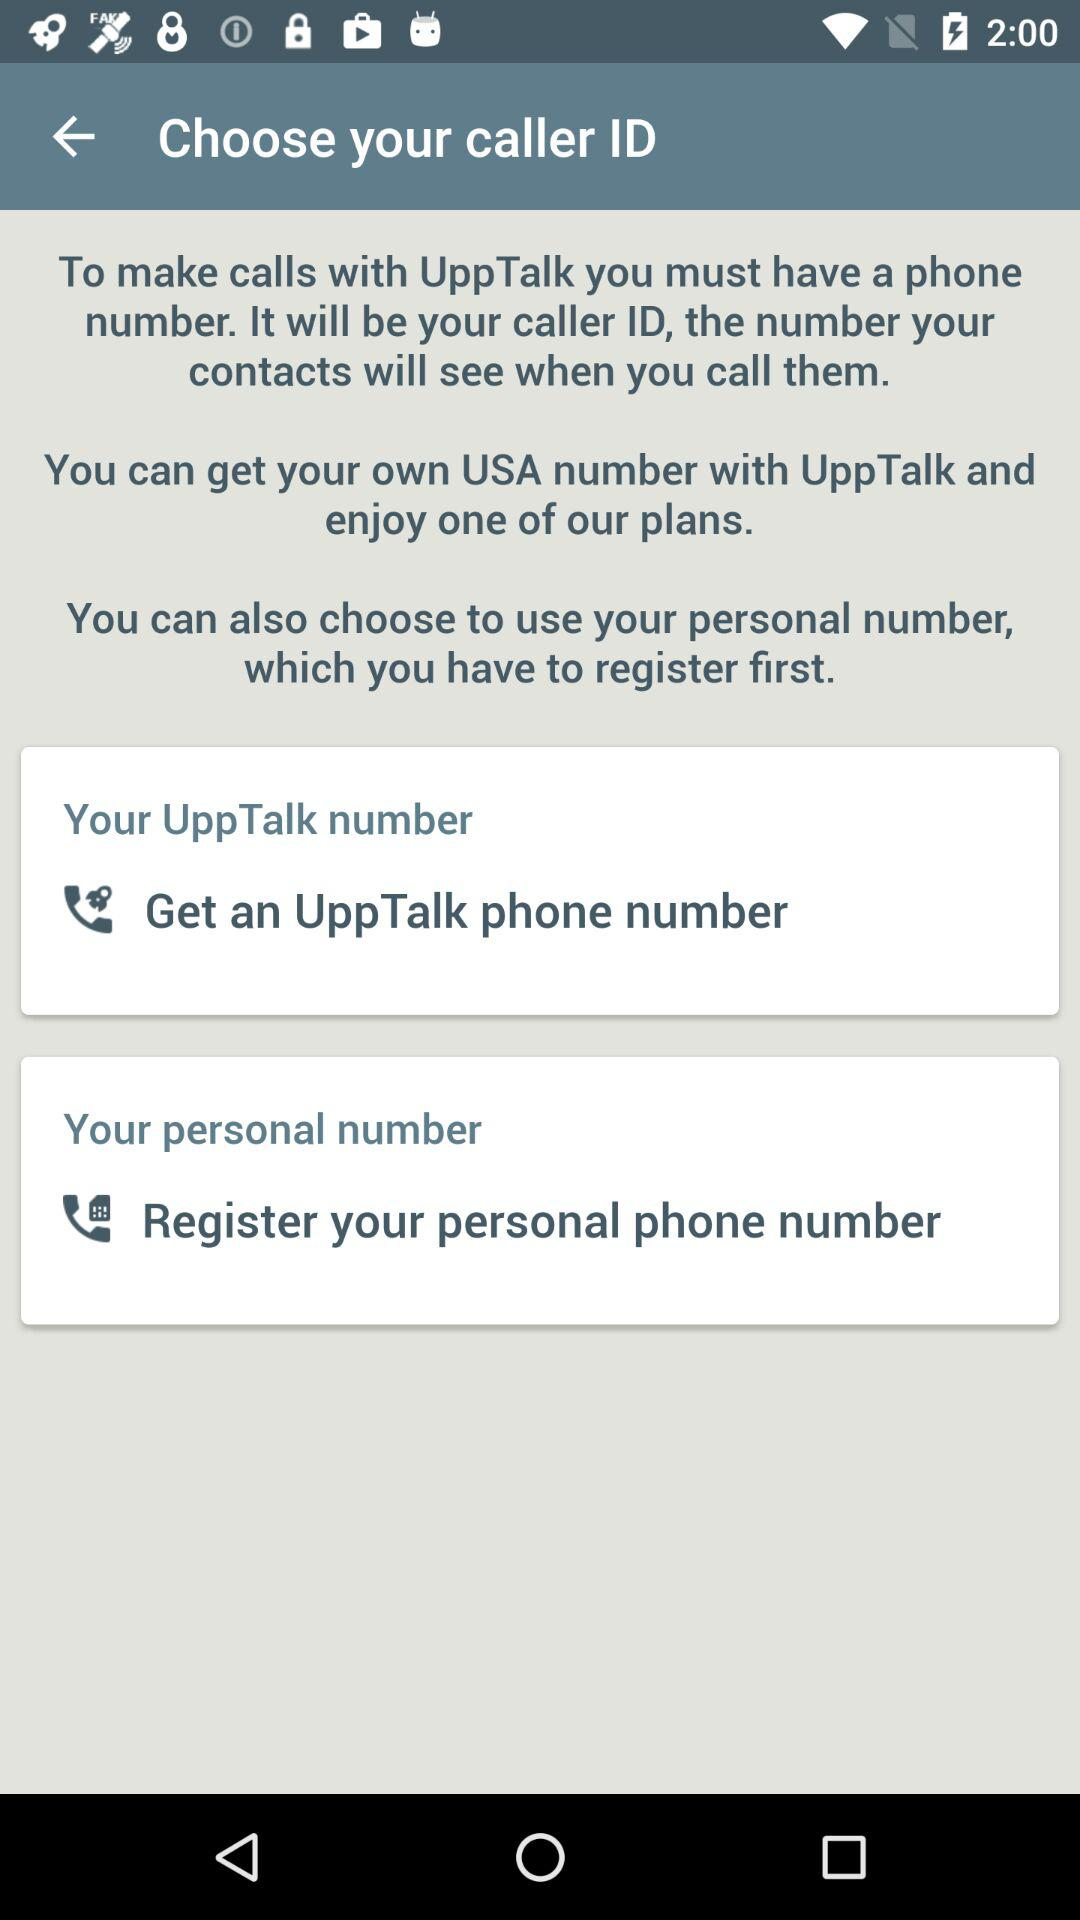What is the application name? The application name is "UppTalk". 